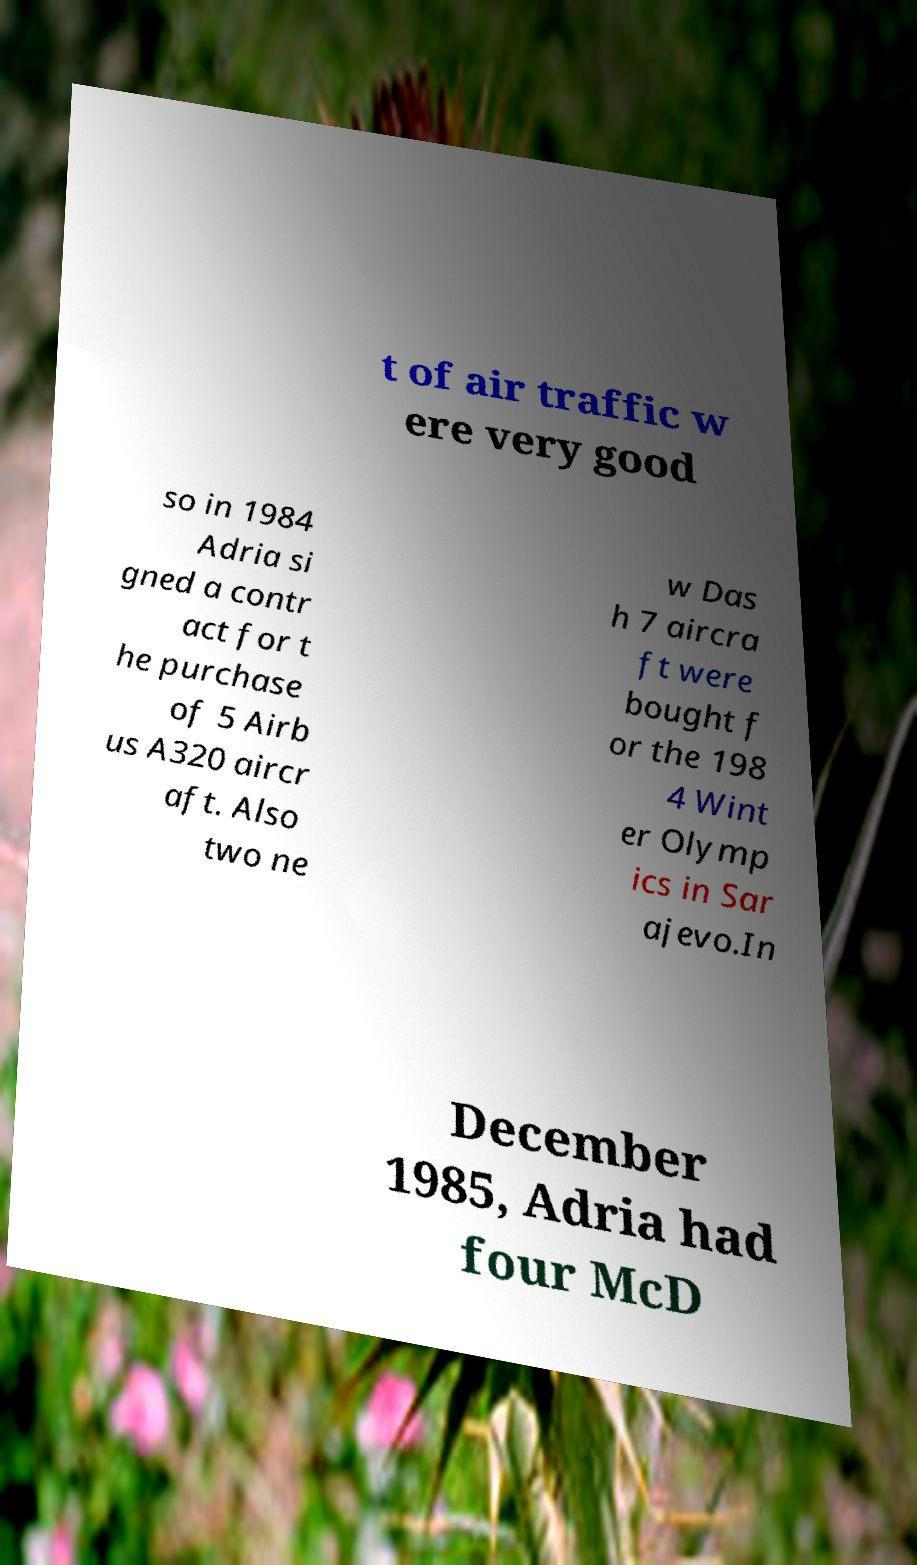Can you read and provide the text displayed in the image?This photo seems to have some interesting text. Can you extract and type it out for me? t of air traffic w ere very good so in 1984 Adria si gned a contr act for t he purchase of 5 Airb us A320 aircr aft. Also two ne w Das h 7 aircra ft were bought f or the 198 4 Wint er Olymp ics in Sar ajevo.In December 1985, Adria had four McD 